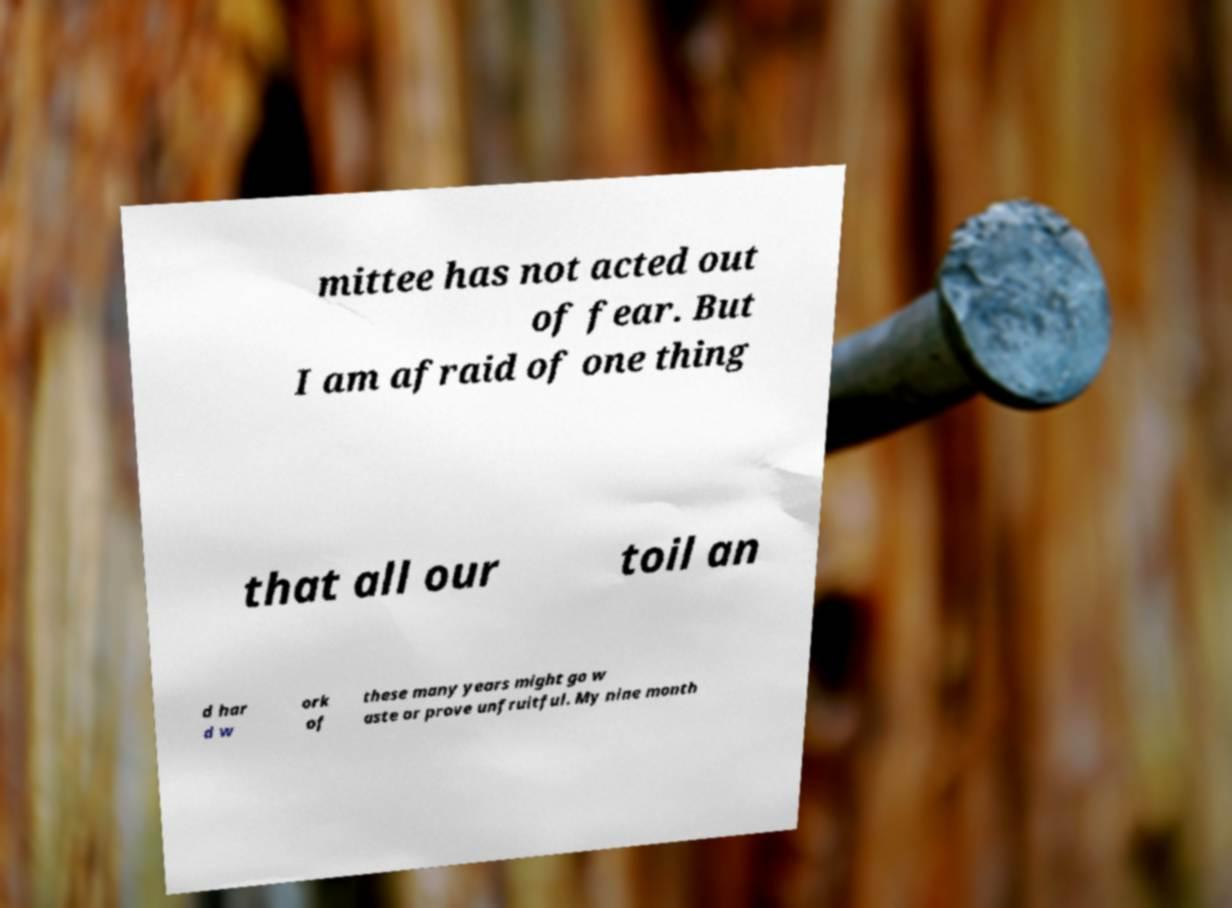For documentation purposes, I need the text within this image transcribed. Could you provide that? mittee has not acted out of fear. But I am afraid of one thing that all our toil an d har d w ork of these many years might go w aste or prove unfruitful. My nine month 